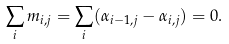<formula> <loc_0><loc_0><loc_500><loc_500>\sum _ { i } m _ { i , j } = \sum _ { i } ( \alpha _ { i - 1 , j } - \alpha _ { i , j } ) = 0 .</formula> 